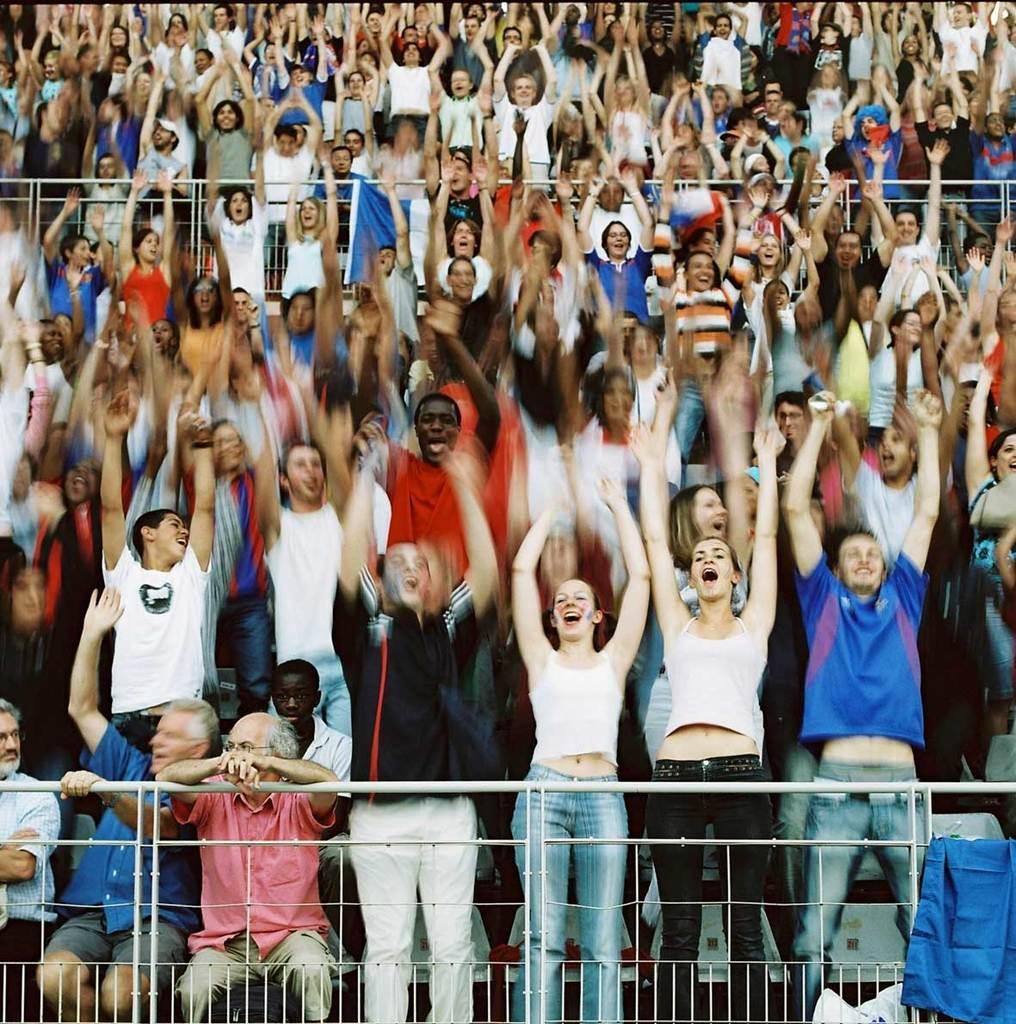What are the people in the image doing? There are people standing on a path and sitting on chairs in the image. What type of structure can be seen in the image? There are iron grills in the image. Is there any signage or decoration visible in the image? Yes, there is a banner in the image. What type of sleet is falling on the people in the image? There is no sleet present in the image; the weather or precipitation cannot be determined from the image. What is the current being used for in the image? There is no mention of a current or electricity in the image; the focus is on the people, chairs, iron grills, and banner. 